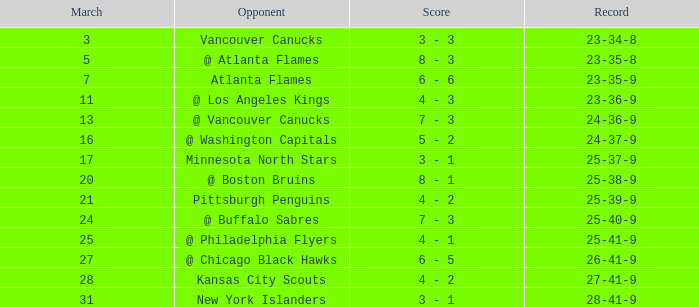Could you parse the entire table as a dict? {'header': ['March', 'Opponent', 'Score', 'Record'], 'rows': [['3', 'Vancouver Canucks', '3 - 3', '23-34-8'], ['5', '@ Atlanta Flames', '8 - 3', '23-35-8'], ['7', 'Atlanta Flames', '6 - 6', '23-35-9'], ['11', '@ Los Angeles Kings', '4 - 3', '23-36-9'], ['13', '@ Vancouver Canucks', '7 - 3', '24-36-9'], ['16', '@ Washington Capitals', '5 - 2', '24-37-9'], ['17', 'Minnesota North Stars', '3 - 1', '25-37-9'], ['20', '@ Boston Bruins', '8 - 1', '25-38-9'], ['21', 'Pittsburgh Penguins', '4 - 2', '25-39-9'], ['24', '@ Buffalo Sabres', '7 - 3', '25-40-9'], ['25', '@ Philadelphia Flyers', '4 - 1', '25-41-9'], ['27', '@ Chicago Black Hawks', '6 - 5', '26-41-9'], ['28', 'Kansas City Scouts', '4 - 2', '27-41-9'], ['31', 'New York Islanders', '3 - 1', '28-41-9']]} What was the score when they had a 25-41-9 record? 4 - 1. 